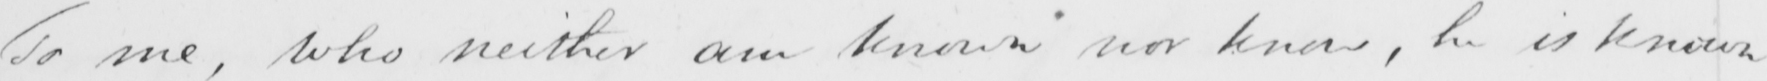What does this handwritten line say? To me , who neither am known nor know , he is known 